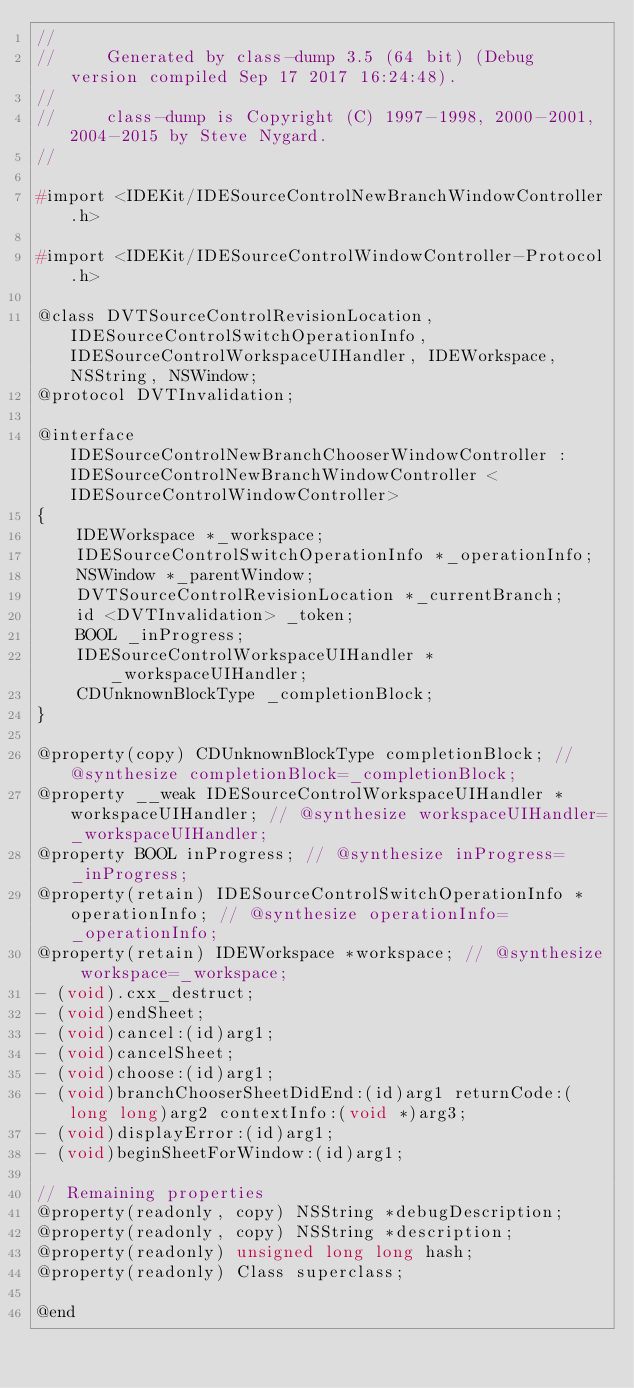<code> <loc_0><loc_0><loc_500><loc_500><_C_>//
//     Generated by class-dump 3.5 (64 bit) (Debug version compiled Sep 17 2017 16:24:48).
//
//     class-dump is Copyright (C) 1997-1998, 2000-2001, 2004-2015 by Steve Nygard.
//

#import <IDEKit/IDESourceControlNewBranchWindowController.h>

#import <IDEKit/IDESourceControlWindowController-Protocol.h>

@class DVTSourceControlRevisionLocation, IDESourceControlSwitchOperationInfo, IDESourceControlWorkspaceUIHandler, IDEWorkspace, NSString, NSWindow;
@protocol DVTInvalidation;

@interface IDESourceControlNewBranchChooserWindowController : IDESourceControlNewBranchWindowController <IDESourceControlWindowController>
{
    IDEWorkspace *_workspace;
    IDESourceControlSwitchOperationInfo *_operationInfo;
    NSWindow *_parentWindow;
    DVTSourceControlRevisionLocation *_currentBranch;
    id <DVTInvalidation> _token;
    BOOL _inProgress;
    IDESourceControlWorkspaceUIHandler *_workspaceUIHandler;
    CDUnknownBlockType _completionBlock;
}

@property(copy) CDUnknownBlockType completionBlock; // @synthesize completionBlock=_completionBlock;
@property __weak IDESourceControlWorkspaceUIHandler *workspaceUIHandler; // @synthesize workspaceUIHandler=_workspaceUIHandler;
@property BOOL inProgress; // @synthesize inProgress=_inProgress;
@property(retain) IDESourceControlSwitchOperationInfo *operationInfo; // @synthesize operationInfo=_operationInfo;
@property(retain) IDEWorkspace *workspace; // @synthesize workspace=_workspace;
- (void).cxx_destruct;
- (void)endSheet;
- (void)cancel:(id)arg1;
- (void)cancelSheet;
- (void)choose:(id)arg1;
- (void)branchChooserSheetDidEnd:(id)arg1 returnCode:(long long)arg2 contextInfo:(void *)arg3;
- (void)displayError:(id)arg1;
- (void)beginSheetForWindow:(id)arg1;

// Remaining properties
@property(readonly, copy) NSString *debugDescription;
@property(readonly, copy) NSString *description;
@property(readonly) unsigned long long hash;
@property(readonly) Class superclass;

@end

</code> 